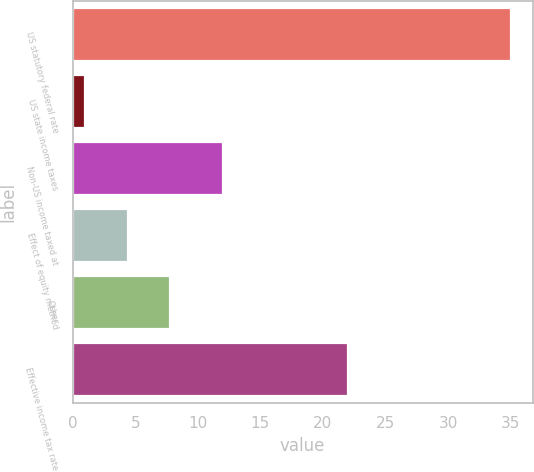<chart> <loc_0><loc_0><loc_500><loc_500><bar_chart><fcel>US statutory federal rate<fcel>US state income taxes<fcel>Non-US income taxed at<fcel>Effect of equity method<fcel>Other<fcel>Effective income tax rate<nl><fcel>35<fcel>1<fcel>12<fcel>4.4<fcel>7.8<fcel>22<nl></chart> 